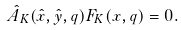<formula> <loc_0><loc_0><loc_500><loc_500>\hat { A } _ { K } ( \hat { x } , \hat { y } , q ) F _ { K } ( x , q ) = 0 .</formula> 